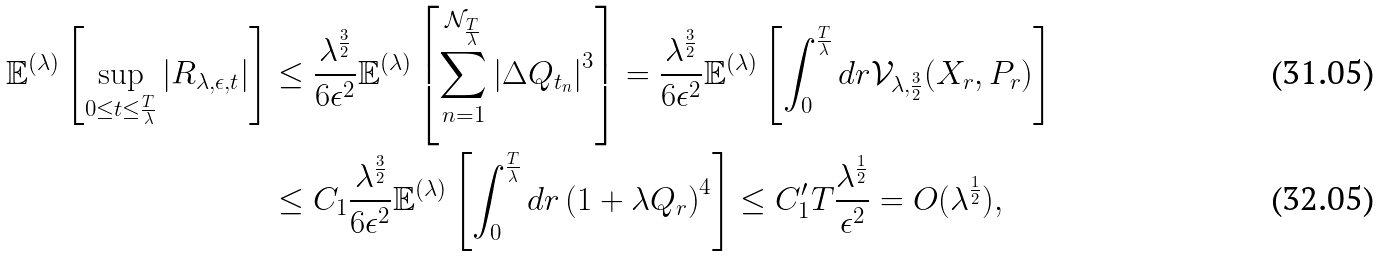Convert formula to latex. <formula><loc_0><loc_0><loc_500><loc_500>\mathbb { E } ^ { ( \lambda ) } \left [ \sup _ { 0 \leq t \leq \frac { T } { \lambda } } \left | R _ { \lambda , \epsilon , t } \right | \right ] & \leq \frac { \lambda ^ { \frac { 3 } { 2 } } } { 6 \epsilon ^ { 2 } } \mathbb { E } ^ { ( \lambda ) } \left [ \sum _ { n = 1 } ^ { \mathcal { N } _ { \frac { T } { \lambda } } } \left | \Delta Q _ { t _ { n } } \right | ^ { 3 } \right ] = \frac { \lambda ^ { \frac { 3 } { 2 } } } { 6 \epsilon ^ { 2 } } \mathbb { E } ^ { ( \lambda ) } \left [ \int _ { 0 } ^ { \frac { T } { \lambda } } d r \mathcal { V } _ { \lambda , \frac { 3 } { 2 } } ( X _ { r } , P _ { r } ) \right ] \\ & \leq C _ { 1 } \frac { \lambda ^ { \frac { 3 } { 2 } } } { 6 \epsilon ^ { 2 } } \mathbb { E } ^ { ( \lambda ) } \left [ \int _ { 0 } ^ { \frac { T } { \lambda } } d r \left ( 1 + \lambda Q _ { r } \right ) ^ { 4 } \right ] \leq C _ { 1 } ^ { \prime } T \frac { \lambda ^ { \frac { 1 } { 2 } } } { \epsilon ^ { 2 } } = O ( \lambda ^ { \frac { 1 } { 2 } } ) ,</formula> 